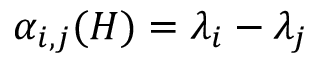Convert formula to latex. <formula><loc_0><loc_0><loc_500><loc_500>\alpha _ { i , j } ( H ) = \lambda _ { i } - \lambda _ { j }</formula> 